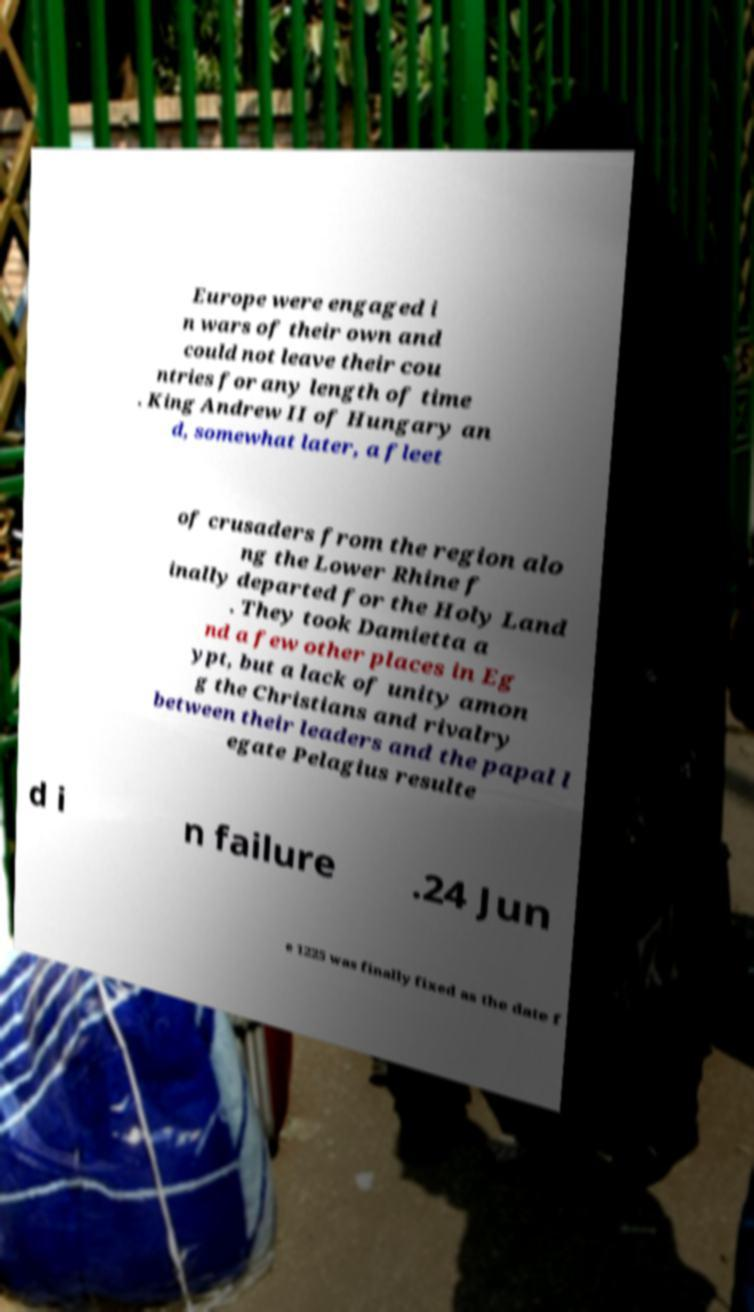Can you read and provide the text displayed in the image?This photo seems to have some interesting text. Can you extract and type it out for me? Europe were engaged i n wars of their own and could not leave their cou ntries for any length of time . King Andrew II of Hungary an d, somewhat later, a fleet of crusaders from the region alo ng the Lower Rhine f inally departed for the Holy Land . They took Damietta a nd a few other places in Eg ypt, but a lack of unity amon g the Christians and rivalry between their leaders and the papal l egate Pelagius resulte d i n failure .24 Jun e 1225 was finally fixed as the date f 